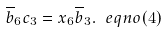<formula> <loc_0><loc_0><loc_500><loc_500>\overline { b } _ { 6 } c _ { 3 } = x _ { 6 } \overline { b } _ { 3 } . \ e q n o ( 4 )</formula> 